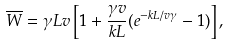<formula> <loc_0><loc_0><loc_500><loc_500>\overline { W } = \gamma L v \left [ 1 + \frac { \gamma v } { k L } ( e ^ { - k L / v \gamma } - 1 ) \right ] ,</formula> 